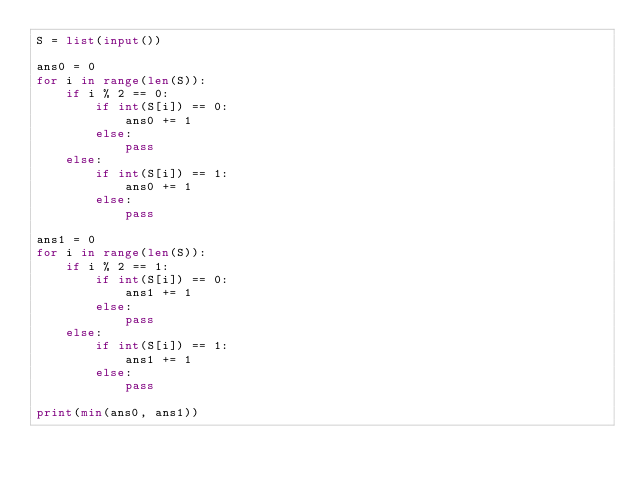<code> <loc_0><loc_0><loc_500><loc_500><_Python_>S = list(input())

ans0 = 0
for i in range(len(S)):
    if i % 2 == 0:
        if int(S[i]) == 0:
            ans0 += 1
        else:
            pass
    else:
        if int(S[i]) == 1:
            ans0 += 1
        else:
            pass

ans1 = 0
for i in range(len(S)):
    if i % 2 == 1:
        if int(S[i]) == 0:
            ans1 += 1
        else:
            pass
    else:
        if int(S[i]) == 1:
            ans1 += 1
        else:
            pass

print(min(ans0, ans1))

</code> 